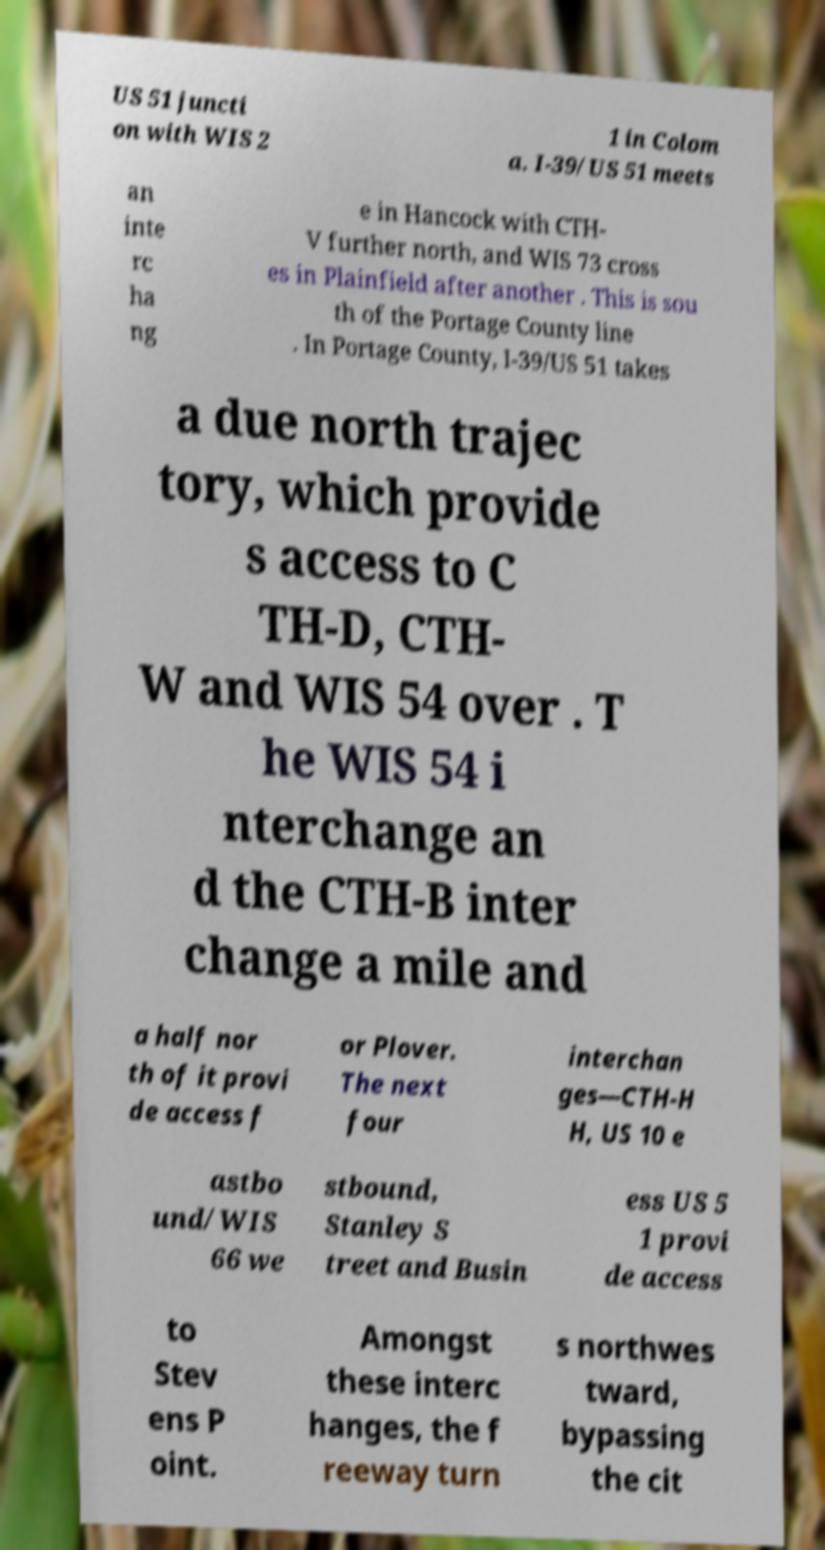What messages or text are displayed in this image? I need them in a readable, typed format. US 51 juncti on with WIS 2 1 in Colom a. I-39/US 51 meets an inte rc ha ng e in Hancock with CTH- V further north, and WIS 73 cross es in Plainfield after another . This is sou th of the Portage County line . In Portage County, I-39/US 51 takes a due north trajec tory, which provide s access to C TH-D, CTH- W and WIS 54 over . T he WIS 54 i nterchange an d the CTH-B inter change a mile and a half nor th of it provi de access f or Plover. The next four interchan ges—CTH-H H, US 10 e astbo und/WIS 66 we stbound, Stanley S treet and Busin ess US 5 1 provi de access to Stev ens P oint. Amongst these interc hanges, the f reeway turn s northwes tward, bypassing the cit 